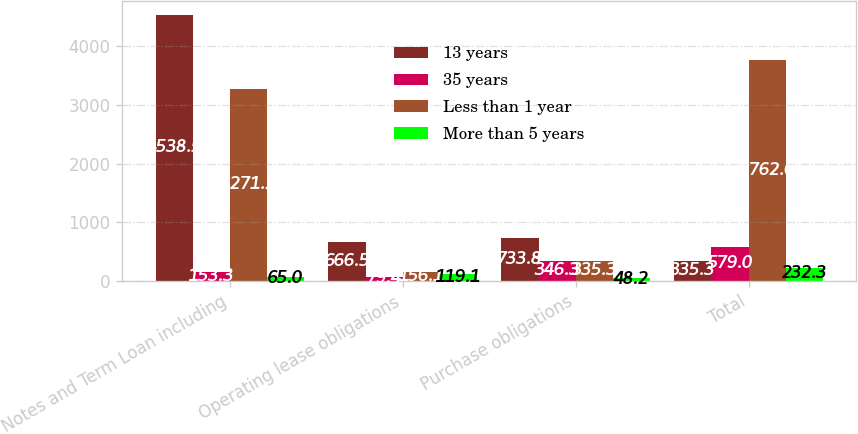Convert chart to OTSL. <chart><loc_0><loc_0><loc_500><loc_500><stacked_bar_chart><ecel><fcel>Notes and Term Loan including<fcel>Operating lease obligations<fcel>Purchase obligations<fcel>Total<nl><fcel>13 years<fcel>4538.5<fcel>666.5<fcel>733.8<fcel>335.3<nl><fcel>35 years<fcel>153.3<fcel>79.4<fcel>346.3<fcel>579<nl><fcel>Less than 1 year<fcel>3271.2<fcel>156.1<fcel>335.3<fcel>3762.6<nl><fcel>More than 5 years<fcel>65<fcel>119.1<fcel>48.2<fcel>232.3<nl></chart> 